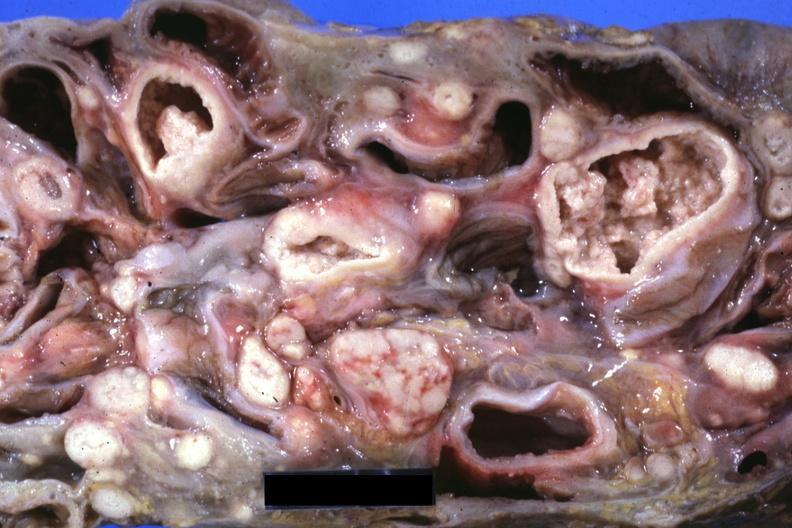what does this image show?
Answer the question using a single word or phrase. Slice through mass of intestines and mesenteric nodes showing lesions that look more like carcinoma but are in fact tuberculosis 